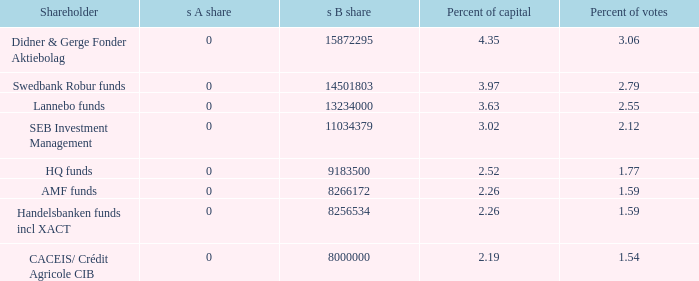Can you identify the shareholder holding 2.55 percent of the votes? Lannebo funds. 